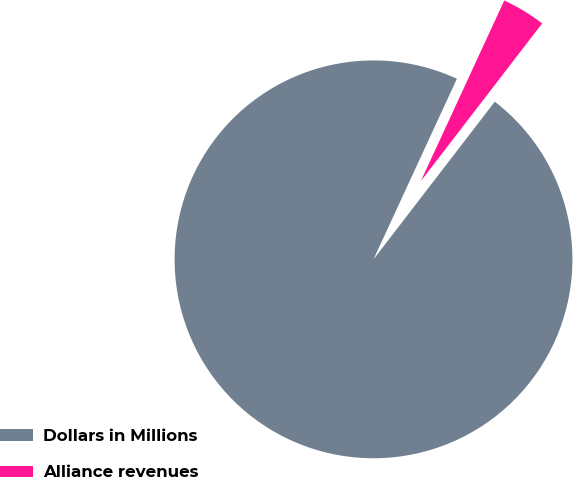Convert chart. <chart><loc_0><loc_0><loc_500><loc_500><pie_chart><fcel>Dollars in Millions<fcel>Alliance revenues<nl><fcel>96.45%<fcel>3.55%<nl></chart> 